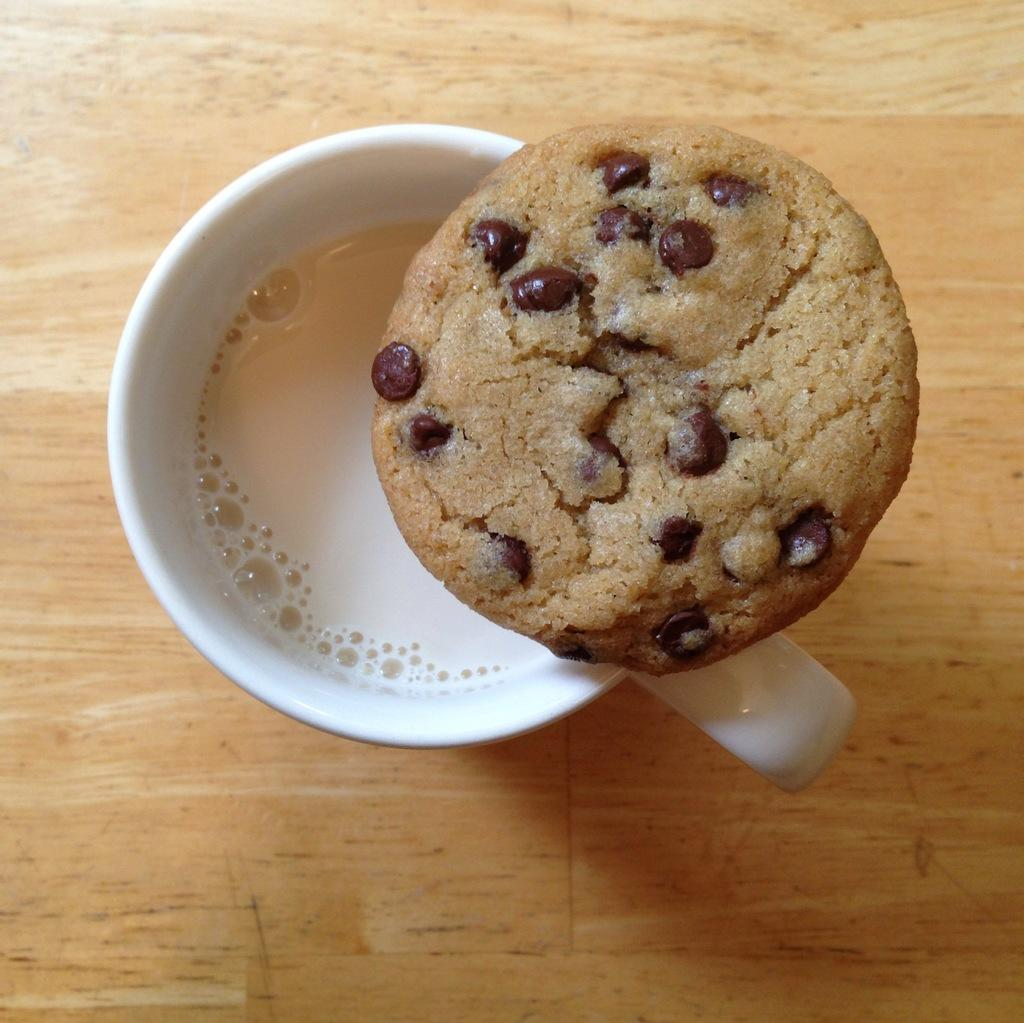What is the main subject of the image? There is a cup of tea in the image. Where is the cup of tea located in the image? The cup of tea is in the center of the image. What is placed on top of the cup of tea? There is a cookie on the cup of tea. What type of toy is sitting next to the cup of tea in the image? There is no toy present in the image; it only features a cup of tea with a cookie on top. 